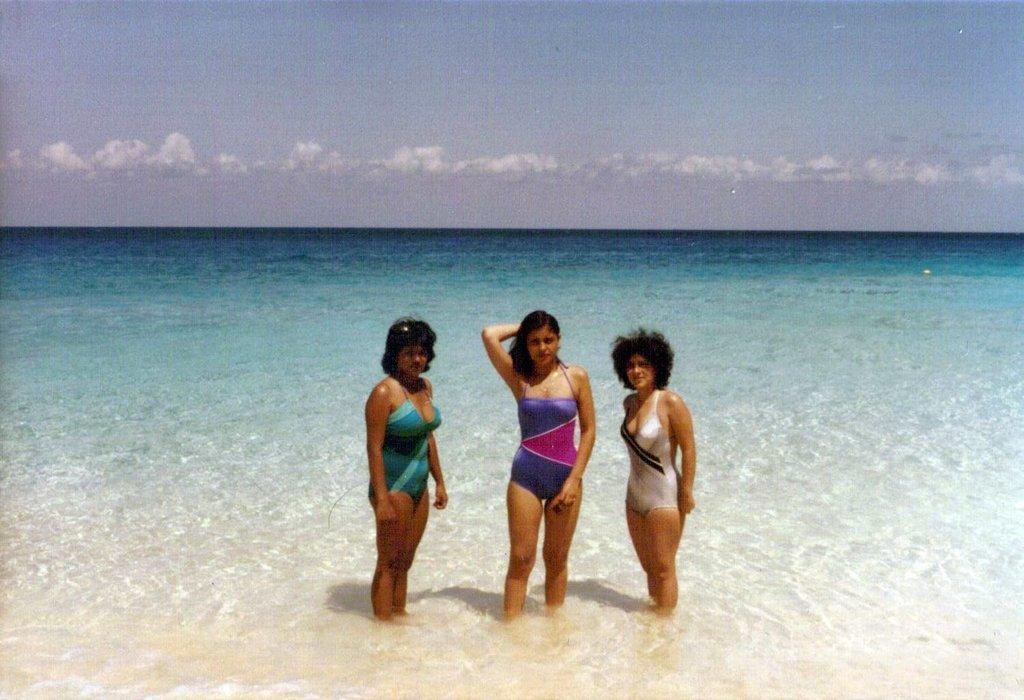Describe this image in one or two sentences. In this image in the center there are women standing in the water. In the background there is an ocean and the sky is cloudy. 